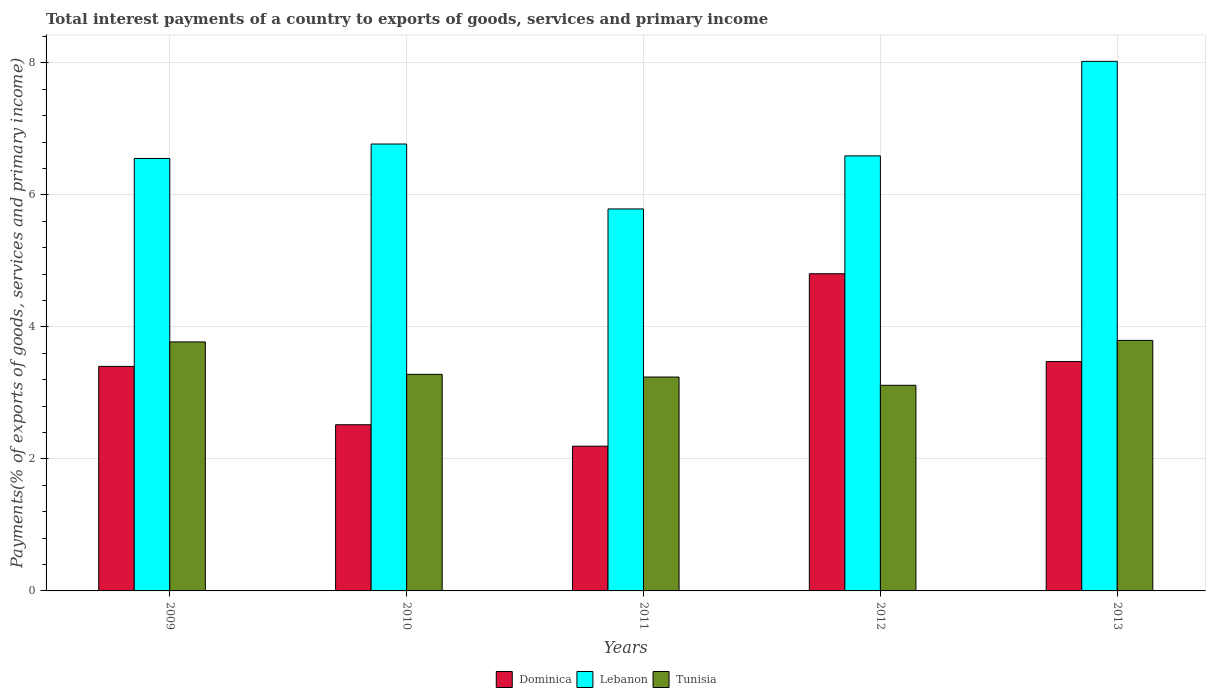Are the number of bars per tick equal to the number of legend labels?
Make the answer very short. Yes. How many bars are there on the 1st tick from the left?
Offer a terse response. 3. How many bars are there on the 4th tick from the right?
Provide a succinct answer. 3. In how many cases, is the number of bars for a given year not equal to the number of legend labels?
Offer a very short reply. 0. What is the total interest payments in Dominica in 2010?
Provide a succinct answer. 2.52. Across all years, what is the maximum total interest payments in Dominica?
Give a very brief answer. 4.8. Across all years, what is the minimum total interest payments in Dominica?
Your response must be concise. 2.19. In which year was the total interest payments in Lebanon maximum?
Give a very brief answer. 2013. In which year was the total interest payments in Tunisia minimum?
Provide a short and direct response. 2012. What is the total total interest payments in Dominica in the graph?
Keep it short and to the point. 16.39. What is the difference between the total interest payments in Tunisia in 2009 and that in 2010?
Make the answer very short. 0.49. What is the difference between the total interest payments in Lebanon in 2010 and the total interest payments in Dominica in 2009?
Your answer should be compact. 3.37. What is the average total interest payments in Dominica per year?
Keep it short and to the point. 3.28. In the year 2010, what is the difference between the total interest payments in Dominica and total interest payments in Tunisia?
Make the answer very short. -0.76. What is the ratio of the total interest payments in Lebanon in 2011 to that in 2013?
Your answer should be compact. 0.72. Is the total interest payments in Dominica in 2010 less than that in 2012?
Provide a short and direct response. Yes. What is the difference between the highest and the second highest total interest payments in Dominica?
Your answer should be very brief. 1.33. What is the difference between the highest and the lowest total interest payments in Lebanon?
Offer a very short reply. 2.24. What does the 2nd bar from the left in 2011 represents?
Your answer should be very brief. Lebanon. What does the 1st bar from the right in 2010 represents?
Your answer should be very brief. Tunisia. How many bars are there?
Offer a terse response. 15. Are the values on the major ticks of Y-axis written in scientific E-notation?
Ensure brevity in your answer.  No. Where does the legend appear in the graph?
Make the answer very short. Bottom center. How many legend labels are there?
Provide a short and direct response. 3. What is the title of the graph?
Provide a succinct answer. Total interest payments of a country to exports of goods, services and primary income. Does "Sint Maarten (Dutch part)" appear as one of the legend labels in the graph?
Offer a terse response. No. What is the label or title of the X-axis?
Offer a terse response. Years. What is the label or title of the Y-axis?
Offer a very short reply. Payments(% of exports of goods, services and primary income). What is the Payments(% of exports of goods, services and primary income) of Dominica in 2009?
Offer a very short reply. 3.4. What is the Payments(% of exports of goods, services and primary income) of Lebanon in 2009?
Your response must be concise. 6.55. What is the Payments(% of exports of goods, services and primary income) of Tunisia in 2009?
Your answer should be compact. 3.77. What is the Payments(% of exports of goods, services and primary income) in Dominica in 2010?
Keep it short and to the point. 2.52. What is the Payments(% of exports of goods, services and primary income) of Lebanon in 2010?
Offer a very short reply. 6.77. What is the Payments(% of exports of goods, services and primary income) of Tunisia in 2010?
Make the answer very short. 3.28. What is the Payments(% of exports of goods, services and primary income) in Dominica in 2011?
Make the answer very short. 2.19. What is the Payments(% of exports of goods, services and primary income) in Lebanon in 2011?
Provide a succinct answer. 5.79. What is the Payments(% of exports of goods, services and primary income) in Tunisia in 2011?
Make the answer very short. 3.24. What is the Payments(% of exports of goods, services and primary income) in Dominica in 2012?
Ensure brevity in your answer.  4.8. What is the Payments(% of exports of goods, services and primary income) in Lebanon in 2012?
Provide a succinct answer. 6.59. What is the Payments(% of exports of goods, services and primary income) in Tunisia in 2012?
Make the answer very short. 3.12. What is the Payments(% of exports of goods, services and primary income) in Dominica in 2013?
Keep it short and to the point. 3.47. What is the Payments(% of exports of goods, services and primary income) of Lebanon in 2013?
Make the answer very short. 8.02. What is the Payments(% of exports of goods, services and primary income) in Tunisia in 2013?
Give a very brief answer. 3.8. Across all years, what is the maximum Payments(% of exports of goods, services and primary income) of Dominica?
Your answer should be very brief. 4.8. Across all years, what is the maximum Payments(% of exports of goods, services and primary income) in Lebanon?
Your answer should be compact. 8.02. Across all years, what is the maximum Payments(% of exports of goods, services and primary income) of Tunisia?
Your answer should be compact. 3.8. Across all years, what is the minimum Payments(% of exports of goods, services and primary income) in Dominica?
Offer a very short reply. 2.19. Across all years, what is the minimum Payments(% of exports of goods, services and primary income) in Lebanon?
Keep it short and to the point. 5.79. Across all years, what is the minimum Payments(% of exports of goods, services and primary income) of Tunisia?
Make the answer very short. 3.12. What is the total Payments(% of exports of goods, services and primary income) of Dominica in the graph?
Your answer should be compact. 16.39. What is the total Payments(% of exports of goods, services and primary income) in Lebanon in the graph?
Give a very brief answer. 33.72. What is the total Payments(% of exports of goods, services and primary income) in Tunisia in the graph?
Give a very brief answer. 17.2. What is the difference between the Payments(% of exports of goods, services and primary income) of Dominica in 2009 and that in 2010?
Ensure brevity in your answer.  0.88. What is the difference between the Payments(% of exports of goods, services and primary income) of Lebanon in 2009 and that in 2010?
Offer a terse response. -0.22. What is the difference between the Payments(% of exports of goods, services and primary income) of Tunisia in 2009 and that in 2010?
Keep it short and to the point. 0.49. What is the difference between the Payments(% of exports of goods, services and primary income) in Dominica in 2009 and that in 2011?
Your answer should be very brief. 1.21. What is the difference between the Payments(% of exports of goods, services and primary income) in Lebanon in 2009 and that in 2011?
Provide a succinct answer. 0.76. What is the difference between the Payments(% of exports of goods, services and primary income) in Tunisia in 2009 and that in 2011?
Offer a very short reply. 0.53. What is the difference between the Payments(% of exports of goods, services and primary income) of Dominica in 2009 and that in 2012?
Your answer should be compact. -1.4. What is the difference between the Payments(% of exports of goods, services and primary income) in Lebanon in 2009 and that in 2012?
Provide a succinct answer. -0.04. What is the difference between the Payments(% of exports of goods, services and primary income) in Tunisia in 2009 and that in 2012?
Make the answer very short. 0.66. What is the difference between the Payments(% of exports of goods, services and primary income) of Dominica in 2009 and that in 2013?
Provide a short and direct response. -0.07. What is the difference between the Payments(% of exports of goods, services and primary income) of Lebanon in 2009 and that in 2013?
Provide a succinct answer. -1.47. What is the difference between the Payments(% of exports of goods, services and primary income) of Tunisia in 2009 and that in 2013?
Provide a succinct answer. -0.02. What is the difference between the Payments(% of exports of goods, services and primary income) of Dominica in 2010 and that in 2011?
Your answer should be very brief. 0.32. What is the difference between the Payments(% of exports of goods, services and primary income) in Lebanon in 2010 and that in 2011?
Give a very brief answer. 0.98. What is the difference between the Payments(% of exports of goods, services and primary income) of Tunisia in 2010 and that in 2011?
Provide a short and direct response. 0.04. What is the difference between the Payments(% of exports of goods, services and primary income) in Dominica in 2010 and that in 2012?
Offer a terse response. -2.29. What is the difference between the Payments(% of exports of goods, services and primary income) in Lebanon in 2010 and that in 2012?
Give a very brief answer. 0.18. What is the difference between the Payments(% of exports of goods, services and primary income) of Tunisia in 2010 and that in 2012?
Ensure brevity in your answer.  0.17. What is the difference between the Payments(% of exports of goods, services and primary income) of Dominica in 2010 and that in 2013?
Give a very brief answer. -0.96. What is the difference between the Payments(% of exports of goods, services and primary income) in Lebanon in 2010 and that in 2013?
Your response must be concise. -1.25. What is the difference between the Payments(% of exports of goods, services and primary income) in Tunisia in 2010 and that in 2013?
Your response must be concise. -0.51. What is the difference between the Payments(% of exports of goods, services and primary income) of Dominica in 2011 and that in 2012?
Ensure brevity in your answer.  -2.61. What is the difference between the Payments(% of exports of goods, services and primary income) in Lebanon in 2011 and that in 2012?
Provide a short and direct response. -0.8. What is the difference between the Payments(% of exports of goods, services and primary income) in Dominica in 2011 and that in 2013?
Provide a succinct answer. -1.28. What is the difference between the Payments(% of exports of goods, services and primary income) of Lebanon in 2011 and that in 2013?
Your answer should be very brief. -2.24. What is the difference between the Payments(% of exports of goods, services and primary income) of Tunisia in 2011 and that in 2013?
Give a very brief answer. -0.56. What is the difference between the Payments(% of exports of goods, services and primary income) of Dominica in 2012 and that in 2013?
Offer a very short reply. 1.33. What is the difference between the Payments(% of exports of goods, services and primary income) in Lebanon in 2012 and that in 2013?
Your response must be concise. -1.43. What is the difference between the Payments(% of exports of goods, services and primary income) in Tunisia in 2012 and that in 2013?
Provide a short and direct response. -0.68. What is the difference between the Payments(% of exports of goods, services and primary income) of Dominica in 2009 and the Payments(% of exports of goods, services and primary income) of Lebanon in 2010?
Provide a short and direct response. -3.37. What is the difference between the Payments(% of exports of goods, services and primary income) in Dominica in 2009 and the Payments(% of exports of goods, services and primary income) in Tunisia in 2010?
Keep it short and to the point. 0.12. What is the difference between the Payments(% of exports of goods, services and primary income) in Lebanon in 2009 and the Payments(% of exports of goods, services and primary income) in Tunisia in 2010?
Make the answer very short. 3.27. What is the difference between the Payments(% of exports of goods, services and primary income) of Dominica in 2009 and the Payments(% of exports of goods, services and primary income) of Lebanon in 2011?
Offer a terse response. -2.39. What is the difference between the Payments(% of exports of goods, services and primary income) in Dominica in 2009 and the Payments(% of exports of goods, services and primary income) in Tunisia in 2011?
Keep it short and to the point. 0.16. What is the difference between the Payments(% of exports of goods, services and primary income) of Lebanon in 2009 and the Payments(% of exports of goods, services and primary income) of Tunisia in 2011?
Offer a terse response. 3.31. What is the difference between the Payments(% of exports of goods, services and primary income) of Dominica in 2009 and the Payments(% of exports of goods, services and primary income) of Lebanon in 2012?
Make the answer very short. -3.19. What is the difference between the Payments(% of exports of goods, services and primary income) in Dominica in 2009 and the Payments(% of exports of goods, services and primary income) in Tunisia in 2012?
Offer a terse response. 0.29. What is the difference between the Payments(% of exports of goods, services and primary income) in Lebanon in 2009 and the Payments(% of exports of goods, services and primary income) in Tunisia in 2012?
Give a very brief answer. 3.44. What is the difference between the Payments(% of exports of goods, services and primary income) of Dominica in 2009 and the Payments(% of exports of goods, services and primary income) of Lebanon in 2013?
Offer a very short reply. -4.62. What is the difference between the Payments(% of exports of goods, services and primary income) of Dominica in 2009 and the Payments(% of exports of goods, services and primary income) of Tunisia in 2013?
Provide a succinct answer. -0.39. What is the difference between the Payments(% of exports of goods, services and primary income) in Lebanon in 2009 and the Payments(% of exports of goods, services and primary income) in Tunisia in 2013?
Your answer should be compact. 2.76. What is the difference between the Payments(% of exports of goods, services and primary income) of Dominica in 2010 and the Payments(% of exports of goods, services and primary income) of Lebanon in 2011?
Offer a very short reply. -3.27. What is the difference between the Payments(% of exports of goods, services and primary income) in Dominica in 2010 and the Payments(% of exports of goods, services and primary income) in Tunisia in 2011?
Make the answer very short. -0.72. What is the difference between the Payments(% of exports of goods, services and primary income) of Lebanon in 2010 and the Payments(% of exports of goods, services and primary income) of Tunisia in 2011?
Your response must be concise. 3.53. What is the difference between the Payments(% of exports of goods, services and primary income) of Dominica in 2010 and the Payments(% of exports of goods, services and primary income) of Lebanon in 2012?
Your answer should be compact. -4.07. What is the difference between the Payments(% of exports of goods, services and primary income) of Dominica in 2010 and the Payments(% of exports of goods, services and primary income) of Tunisia in 2012?
Provide a short and direct response. -0.6. What is the difference between the Payments(% of exports of goods, services and primary income) of Lebanon in 2010 and the Payments(% of exports of goods, services and primary income) of Tunisia in 2012?
Your response must be concise. 3.65. What is the difference between the Payments(% of exports of goods, services and primary income) of Dominica in 2010 and the Payments(% of exports of goods, services and primary income) of Lebanon in 2013?
Ensure brevity in your answer.  -5.5. What is the difference between the Payments(% of exports of goods, services and primary income) in Dominica in 2010 and the Payments(% of exports of goods, services and primary income) in Tunisia in 2013?
Your response must be concise. -1.28. What is the difference between the Payments(% of exports of goods, services and primary income) in Lebanon in 2010 and the Payments(% of exports of goods, services and primary income) in Tunisia in 2013?
Make the answer very short. 2.97. What is the difference between the Payments(% of exports of goods, services and primary income) in Dominica in 2011 and the Payments(% of exports of goods, services and primary income) in Lebanon in 2012?
Keep it short and to the point. -4.4. What is the difference between the Payments(% of exports of goods, services and primary income) in Dominica in 2011 and the Payments(% of exports of goods, services and primary income) in Tunisia in 2012?
Your answer should be very brief. -0.92. What is the difference between the Payments(% of exports of goods, services and primary income) of Lebanon in 2011 and the Payments(% of exports of goods, services and primary income) of Tunisia in 2012?
Provide a short and direct response. 2.67. What is the difference between the Payments(% of exports of goods, services and primary income) of Dominica in 2011 and the Payments(% of exports of goods, services and primary income) of Lebanon in 2013?
Offer a terse response. -5.83. What is the difference between the Payments(% of exports of goods, services and primary income) in Dominica in 2011 and the Payments(% of exports of goods, services and primary income) in Tunisia in 2013?
Your answer should be very brief. -1.6. What is the difference between the Payments(% of exports of goods, services and primary income) of Lebanon in 2011 and the Payments(% of exports of goods, services and primary income) of Tunisia in 2013?
Your response must be concise. 1.99. What is the difference between the Payments(% of exports of goods, services and primary income) in Dominica in 2012 and the Payments(% of exports of goods, services and primary income) in Lebanon in 2013?
Provide a short and direct response. -3.22. What is the difference between the Payments(% of exports of goods, services and primary income) of Dominica in 2012 and the Payments(% of exports of goods, services and primary income) of Tunisia in 2013?
Keep it short and to the point. 1.01. What is the difference between the Payments(% of exports of goods, services and primary income) of Lebanon in 2012 and the Payments(% of exports of goods, services and primary income) of Tunisia in 2013?
Make the answer very short. 2.8. What is the average Payments(% of exports of goods, services and primary income) of Dominica per year?
Your answer should be very brief. 3.28. What is the average Payments(% of exports of goods, services and primary income) in Lebanon per year?
Your response must be concise. 6.74. What is the average Payments(% of exports of goods, services and primary income) of Tunisia per year?
Offer a very short reply. 3.44. In the year 2009, what is the difference between the Payments(% of exports of goods, services and primary income) in Dominica and Payments(% of exports of goods, services and primary income) in Lebanon?
Ensure brevity in your answer.  -3.15. In the year 2009, what is the difference between the Payments(% of exports of goods, services and primary income) in Dominica and Payments(% of exports of goods, services and primary income) in Tunisia?
Provide a succinct answer. -0.37. In the year 2009, what is the difference between the Payments(% of exports of goods, services and primary income) in Lebanon and Payments(% of exports of goods, services and primary income) in Tunisia?
Ensure brevity in your answer.  2.78. In the year 2010, what is the difference between the Payments(% of exports of goods, services and primary income) of Dominica and Payments(% of exports of goods, services and primary income) of Lebanon?
Make the answer very short. -4.25. In the year 2010, what is the difference between the Payments(% of exports of goods, services and primary income) in Dominica and Payments(% of exports of goods, services and primary income) in Tunisia?
Ensure brevity in your answer.  -0.76. In the year 2010, what is the difference between the Payments(% of exports of goods, services and primary income) in Lebanon and Payments(% of exports of goods, services and primary income) in Tunisia?
Your answer should be compact. 3.49. In the year 2011, what is the difference between the Payments(% of exports of goods, services and primary income) in Dominica and Payments(% of exports of goods, services and primary income) in Lebanon?
Ensure brevity in your answer.  -3.59. In the year 2011, what is the difference between the Payments(% of exports of goods, services and primary income) in Dominica and Payments(% of exports of goods, services and primary income) in Tunisia?
Your response must be concise. -1.05. In the year 2011, what is the difference between the Payments(% of exports of goods, services and primary income) in Lebanon and Payments(% of exports of goods, services and primary income) in Tunisia?
Offer a terse response. 2.55. In the year 2012, what is the difference between the Payments(% of exports of goods, services and primary income) of Dominica and Payments(% of exports of goods, services and primary income) of Lebanon?
Ensure brevity in your answer.  -1.79. In the year 2012, what is the difference between the Payments(% of exports of goods, services and primary income) in Dominica and Payments(% of exports of goods, services and primary income) in Tunisia?
Your answer should be compact. 1.69. In the year 2012, what is the difference between the Payments(% of exports of goods, services and primary income) in Lebanon and Payments(% of exports of goods, services and primary income) in Tunisia?
Your answer should be very brief. 3.48. In the year 2013, what is the difference between the Payments(% of exports of goods, services and primary income) of Dominica and Payments(% of exports of goods, services and primary income) of Lebanon?
Provide a succinct answer. -4.55. In the year 2013, what is the difference between the Payments(% of exports of goods, services and primary income) of Dominica and Payments(% of exports of goods, services and primary income) of Tunisia?
Give a very brief answer. -0.32. In the year 2013, what is the difference between the Payments(% of exports of goods, services and primary income) of Lebanon and Payments(% of exports of goods, services and primary income) of Tunisia?
Make the answer very short. 4.23. What is the ratio of the Payments(% of exports of goods, services and primary income) in Dominica in 2009 to that in 2010?
Offer a very short reply. 1.35. What is the ratio of the Payments(% of exports of goods, services and primary income) in Lebanon in 2009 to that in 2010?
Make the answer very short. 0.97. What is the ratio of the Payments(% of exports of goods, services and primary income) of Tunisia in 2009 to that in 2010?
Provide a short and direct response. 1.15. What is the ratio of the Payments(% of exports of goods, services and primary income) in Dominica in 2009 to that in 2011?
Ensure brevity in your answer.  1.55. What is the ratio of the Payments(% of exports of goods, services and primary income) in Lebanon in 2009 to that in 2011?
Ensure brevity in your answer.  1.13. What is the ratio of the Payments(% of exports of goods, services and primary income) of Tunisia in 2009 to that in 2011?
Give a very brief answer. 1.16. What is the ratio of the Payments(% of exports of goods, services and primary income) of Dominica in 2009 to that in 2012?
Keep it short and to the point. 0.71. What is the ratio of the Payments(% of exports of goods, services and primary income) of Tunisia in 2009 to that in 2012?
Offer a very short reply. 1.21. What is the ratio of the Payments(% of exports of goods, services and primary income) in Dominica in 2009 to that in 2013?
Provide a succinct answer. 0.98. What is the ratio of the Payments(% of exports of goods, services and primary income) of Lebanon in 2009 to that in 2013?
Provide a succinct answer. 0.82. What is the ratio of the Payments(% of exports of goods, services and primary income) of Tunisia in 2009 to that in 2013?
Your answer should be compact. 0.99. What is the ratio of the Payments(% of exports of goods, services and primary income) in Dominica in 2010 to that in 2011?
Provide a succinct answer. 1.15. What is the ratio of the Payments(% of exports of goods, services and primary income) in Lebanon in 2010 to that in 2011?
Provide a succinct answer. 1.17. What is the ratio of the Payments(% of exports of goods, services and primary income) in Tunisia in 2010 to that in 2011?
Your answer should be compact. 1.01. What is the ratio of the Payments(% of exports of goods, services and primary income) in Dominica in 2010 to that in 2012?
Provide a succinct answer. 0.52. What is the ratio of the Payments(% of exports of goods, services and primary income) of Lebanon in 2010 to that in 2012?
Your answer should be very brief. 1.03. What is the ratio of the Payments(% of exports of goods, services and primary income) in Tunisia in 2010 to that in 2012?
Your answer should be compact. 1.05. What is the ratio of the Payments(% of exports of goods, services and primary income) of Dominica in 2010 to that in 2013?
Make the answer very short. 0.72. What is the ratio of the Payments(% of exports of goods, services and primary income) of Lebanon in 2010 to that in 2013?
Offer a terse response. 0.84. What is the ratio of the Payments(% of exports of goods, services and primary income) in Tunisia in 2010 to that in 2013?
Keep it short and to the point. 0.86. What is the ratio of the Payments(% of exports of goods, services and primary income) in Dominica in 2011 to that in 2012?
Ensure brevity in your answer.  0.46. What is the ratio of the Payments(% of exports of goods, services and primary income) in Lebanon in 2011 to that in 2012?
Keep it short and to the point. 0.88. What is the ratio of the Payments(% of exports of goods, services and primary income) in Tunisia in 2011 to that in 2012?
Your answer should be compact. 1.04. What is the ratio of the Payments(% of exports of goods, services and primary income) of Dominica in 2011 to that in 2013?
Offer a terse response. 0.63. What is the ratio of the Payments(% of exports of goods, services and primary income) in Lebanon in 2011 to that in 2013?
Ensure brevity in your answer.  0.72. What is the ratio of the Payments(% of exports of goods, services and primary income) in Tunisia in 2011 to that in 2013?
Ensure brevity in your answer.  0.85. What is the ratio of the Payments(% of exports of goods, services and primary income) in Dominica in 2012 to that in 2013?
Provide a succinct answer. 1.38. What is the ratio of the Payments(% of exports of goods, services and primary income) in Lebanon in 2012 to that in 2013?
Offer a very short reply. 0.82. What is the ratio of the Payments(% of exports of goods, services and primary income) of Tunisia in 2012 to that in 2013?
Your answer should be very brief. 0.82. What is the difference between the highest and the second highest Payments(% of exports of goods, services and primary income) of Dominica?
Your answer should be compact. 1.33. What is the difference between the highest and the second highest Payments(% of exports of goods, services and primary income) in Lebanon?
Make the answer very short. 1.25. What is the difference between the highest and the second highest Payments(% of exports of goods, services and primary income) in Tunisia?
Keep it short and to the point. 0.02. What is the difference between the highest and the lowest Payments(% of exports of goods, services and primary income) of Dominica?
Provide a succinct answer. 2.61. What is the difference between the highest and the lowest Payments(% of exports of goods, services and primary income) in Lebanon?
Give a very brief answer. 2.24. What is the difference between the highest and the lowest Payments(% of exports of goods, services and primary income) in Tunisia?
Offer a very short reply. 0.68. 